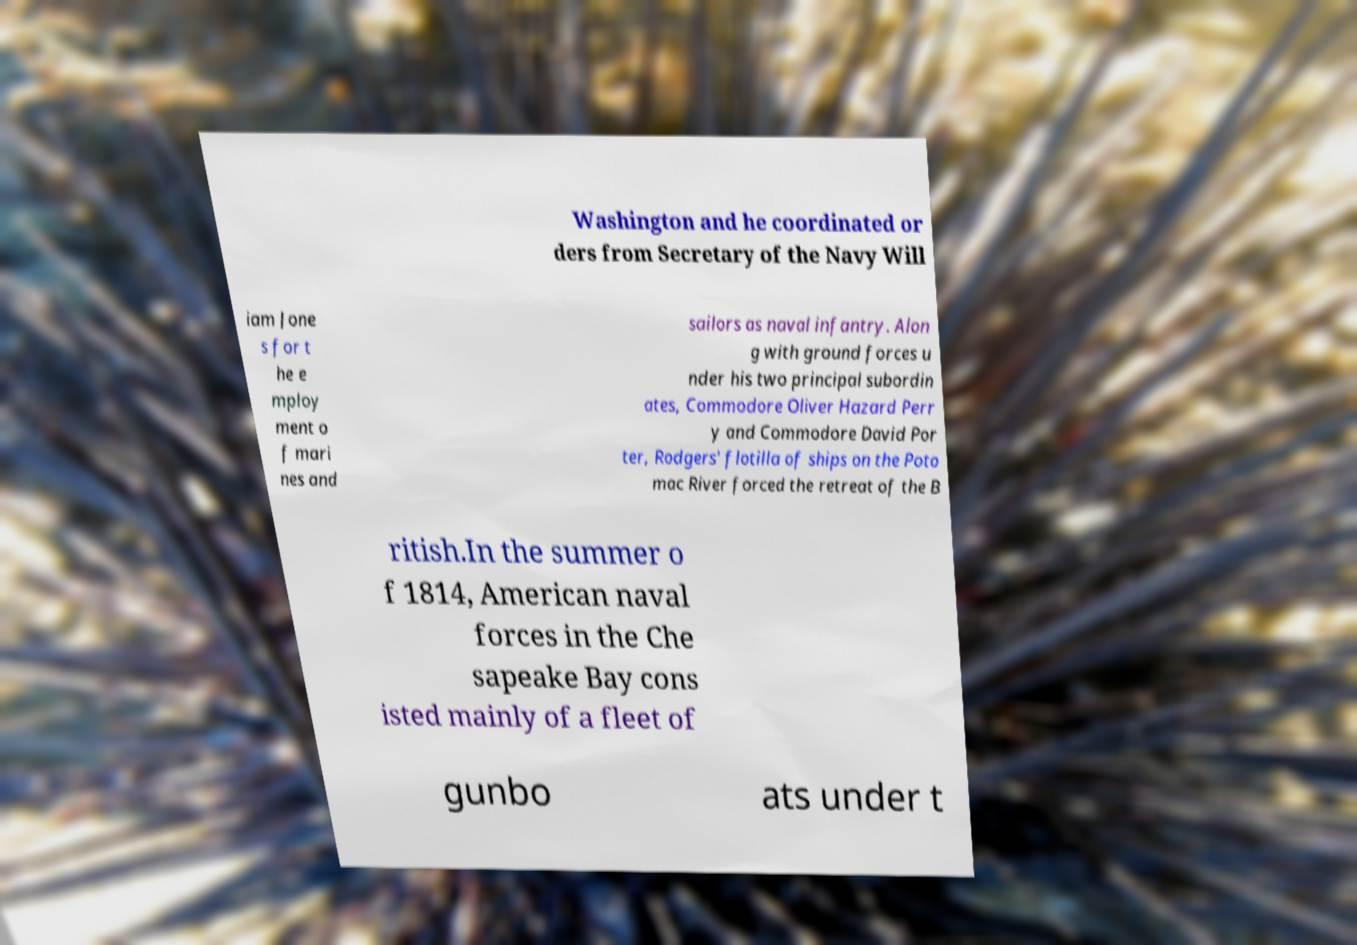Could you extract and type out the text from this image? Washington and he coordinated or ders from Secretary of the Navy Will iam Jone s for t he e mploy ment o f mari nes and sailors as naval infantry. Alon g with ground forces u nder his two principal subordin ates, Commodore Oliver Hazard Perr y and Commodore David Por ter, Rodgers' flotilla of ships on the Poto mac River forced the retreat of the B ritish.In the summer o f 1814, American naval forces in the Che sapeake Bay cons isted mainly of a fleet of gunbo ats under t 